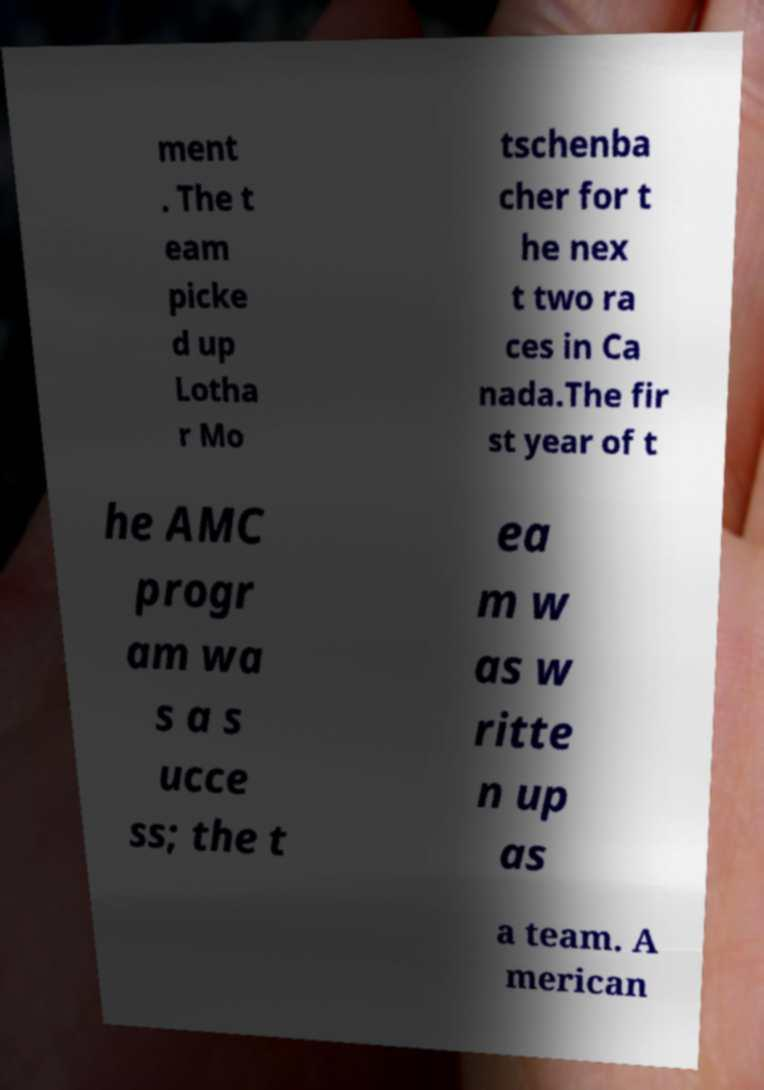There's text embedded in this image that I need extracted. Can you transcribe it verbatim? ment . The t eam picke d up Lotha r Mo tschenba cher for t he nex t two ra ces in Ca nada.The fir st year of t he AMC progr am wa s a s ucce ss; the t ea m w as w ritte n up as a team. A merican 